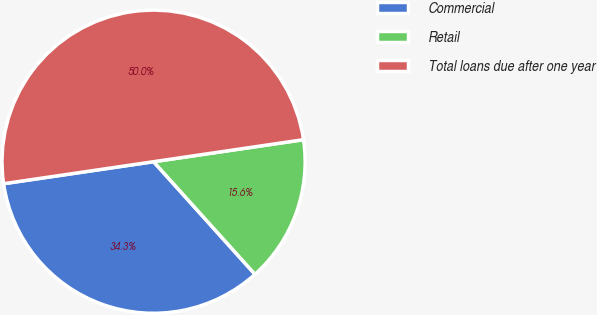Convert chart to OTSL. <chart><loc_0><loc_0><loc_500><loc_500><pie_chart><fcel>Commercial<fcel>Retail<fcel>Total loans due after one year<nl><fcel>34.35%<fcel>15.65%<fcel>50.0%<nl></chart> 